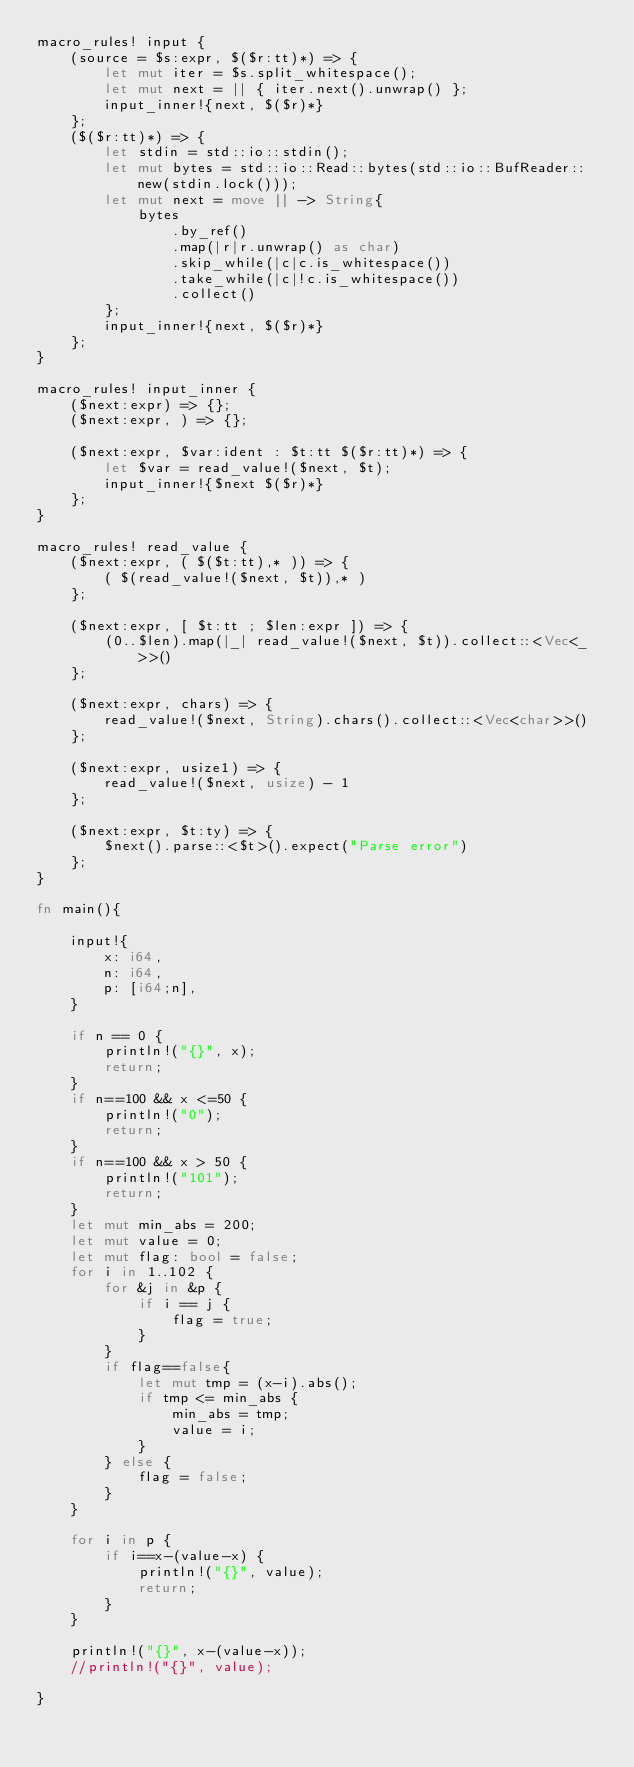Convert code to text. <code><loc_0><loc_0><loc_500><loc_500><_Rust_>macro_rules! input {
    (source = $s:expr, $($r:tt)*) => {
        let mut iter = $s.split_whitespace();
        let mut next = || { iter.next().unwrap() };
        input_inner!{next, $($r)*}
    };
    ($($r:tt)*) => {
        let stdin = std::io::stdin();
        let mut bytes = std::io::Read::bytes(std::io::BufReader::new(stdin.lock()));
        let mut next = move || -> String{
            bytes
                .by_ref()
                .map(|r|r.unwrap() as char)
                .skip_while(|c|c.is_whitespace())
                .take_while(|c|!c.is_whitespace())
                .collect()
        };
        input_inner!{next, $($r)*}
    };
}

macro_rules! input_inner {
    ($next:expr) => {};
    ($next:expr, ) => {};

    ($next:expr, $var:ident : $t:tt $($r:tt)*) => {
        let $var = read_value!($next, $t);
        input_inner!{$next $($r)*}
    };
}

macro_rules! read_value {
    ($next:expr, ( $($t:tt),* )) => {
        ( $(read_value!($next, $t)),* )
    };

    ($next:expr, [ $t:tt ; $len:expr ]) => {
        (0..$len).map(|_| read_value!($next, $t)).collect::<Vec<_>>()
    };

    ($next:expr, chars) => {
        read_value!($next, String).chars().collect::<Vec<char>>()
    };

    ($next:expr, usize1) => {
        read_value!($next, usize) - 1
    };

    ($next:expr, $t:ty) => {
        $next().parse::<$t>().expect("Parse error")
    };
}

fn main(){

    input!{
        x: i64,
        n: i64,
        p: [i64;n],
    }

    if n == 0 {
        println!("{}", x);
        return;
    }
    if n==100 && x <=50 {
        println!("0");
        return;
    }
    if n==100 && x > 50 {
        println!("101");
        return;
    }
    let mut min_abs = 200;
    let mut value = 0;
    let mut flag: bool = false;
    for i in 1..102 {
        for &j in &p {
            if i == j {
                flag = true;
            }
        }
        if flag==false{
            let mut tmp = (x-i).abs();
            if tmp <= min_abs {
                min_abs = tmp;
                value = i;
            }
        } else {
            flag = false;
        }
    }

    for i in p {
        if i==x-(value-x) {
            println!("{}", value);
            return;
        }
    }

    println!("{}", x-(value-x));
    //println!("{}", value);

}</code> 